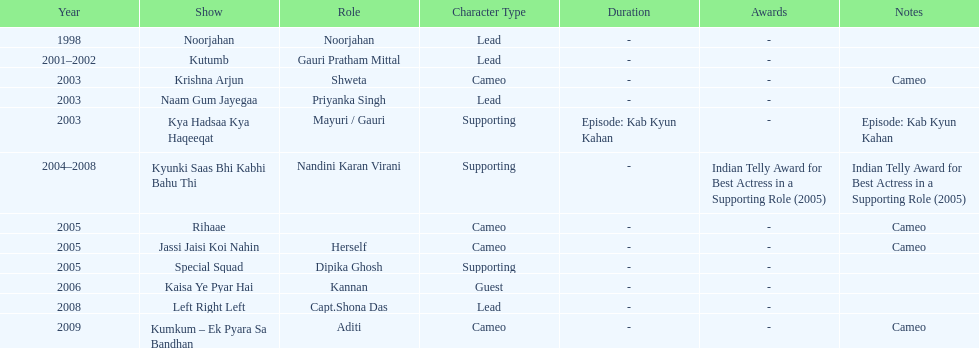What was the first tv series that gauri tejwani appeared in? Noorjahan. 